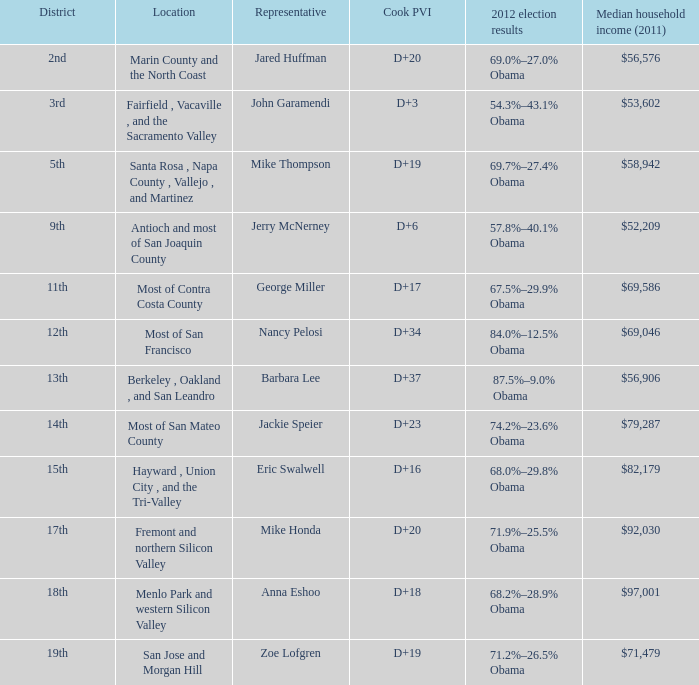How many election results in 2012 had a Cook PVI of D+16? 1.0. 